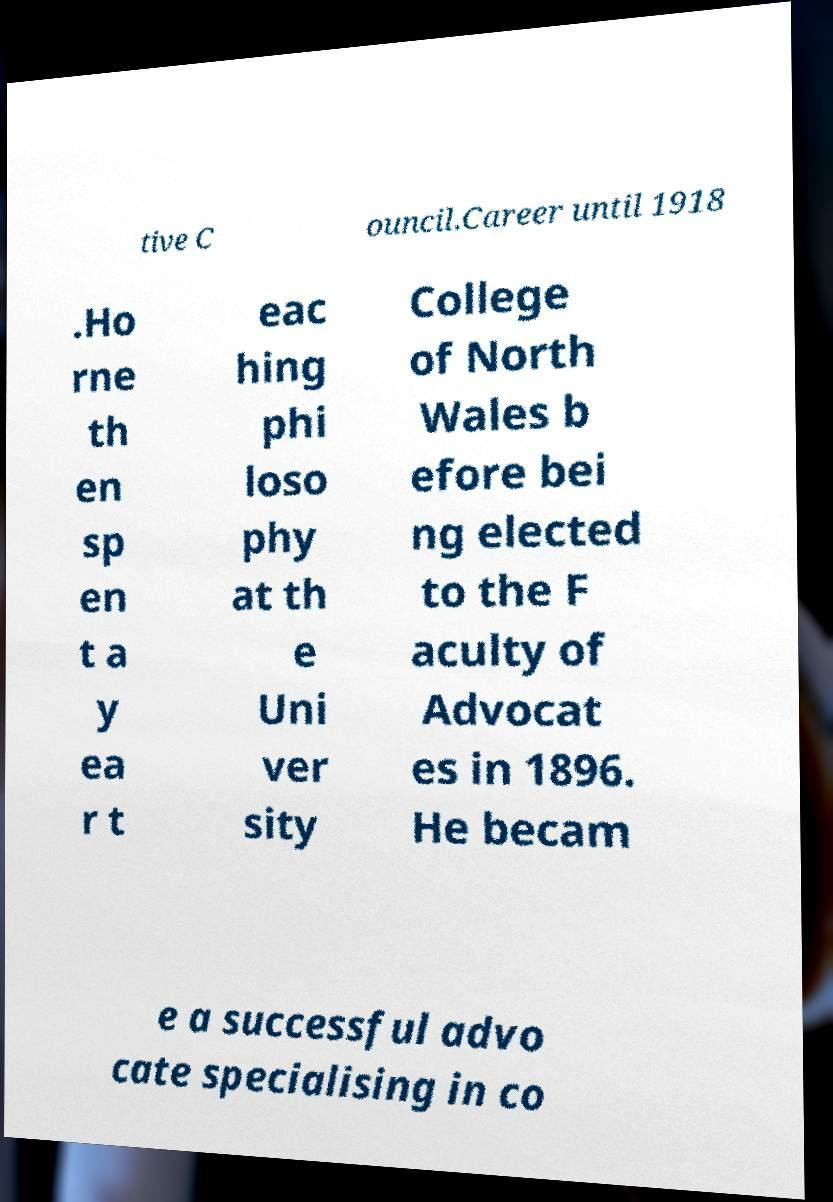There's text embedded in this image that I need extracted. Can you transcribe it verbatim? tive C ouncil.Career until 1918 .Ho rne th en sp en t a y ea r t eac hing phi loso phy at th e Uni ver sity College of North Wales b efore bei ng elected to the F aculty of Advocat es in 1896. He becam e a successful advo cate specialising in co 